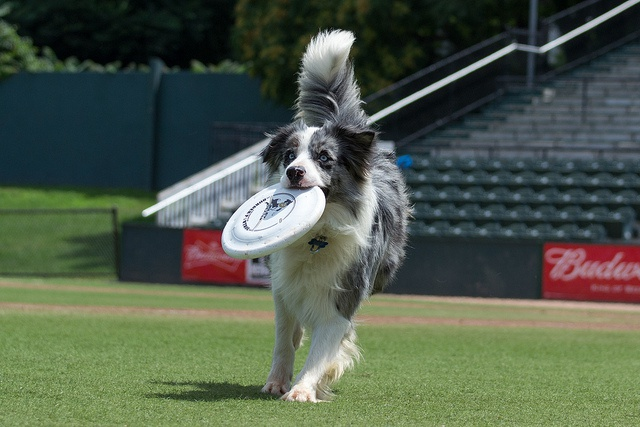Describe the objects in this image and their specific colors. I can see dog in black, gray, darkgray, and lightgray tones and frisbee in black, white, darkgray, and lightblue tones in this image. 